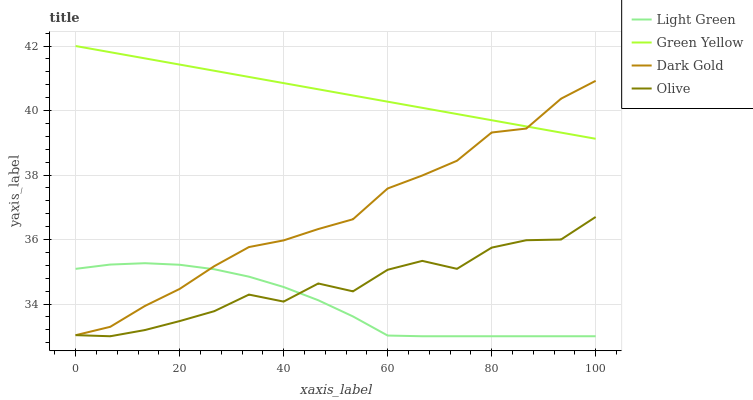Does Green Yellow have the minimum area under the curve?
Answer yes or no. No. Does Light Green have the maximum area under the curve?
Answer yes or no. No. Is Light Green the smoothest?
Answer yes or no. No. Is Light Green the roughest?
Answer yes or no. No. Does Green Yellow have the lowest value?
Answer yes or no. No. Does Light Green have the highest value?
Answer yes or no. No. Is Light Green less than Green Yellow?
Answer yes or no. Yes. Is Green Yellow greater than Olive?
Answer yes or no. Yes. Does Light Green intersect Green Yellow?
Answer yes or no. No. 